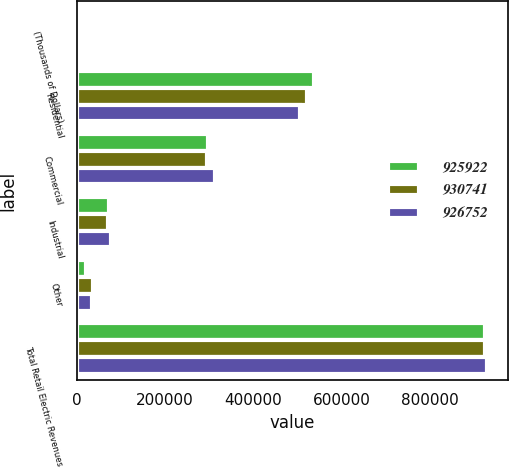Convert chart. <chart><loc_0><loc_0><loc_500><loc_500><stacked_bar_chart><ecel><fcel>(Thousands of Dollars)<fcel>Residential<fcel>Commercial<fcel>Industrial<fcel>Other<fcel>Total Retail Electric Revenues<nl><fcel>925922<fcel>2017<fcel>537439<fcel>297342<fcel>72371<fcel>19600<fcel>926752<nl><fcel>930741<fcel>2016<fcel>521914<fcel>295956<fcel>70864<fcel>37188<fcel>925922<nl><fcel>926752<fcel>2015<fcel>505806<fcel>312918<fcel>76914<fcel>35103<fcel>930741<nl></chart> 